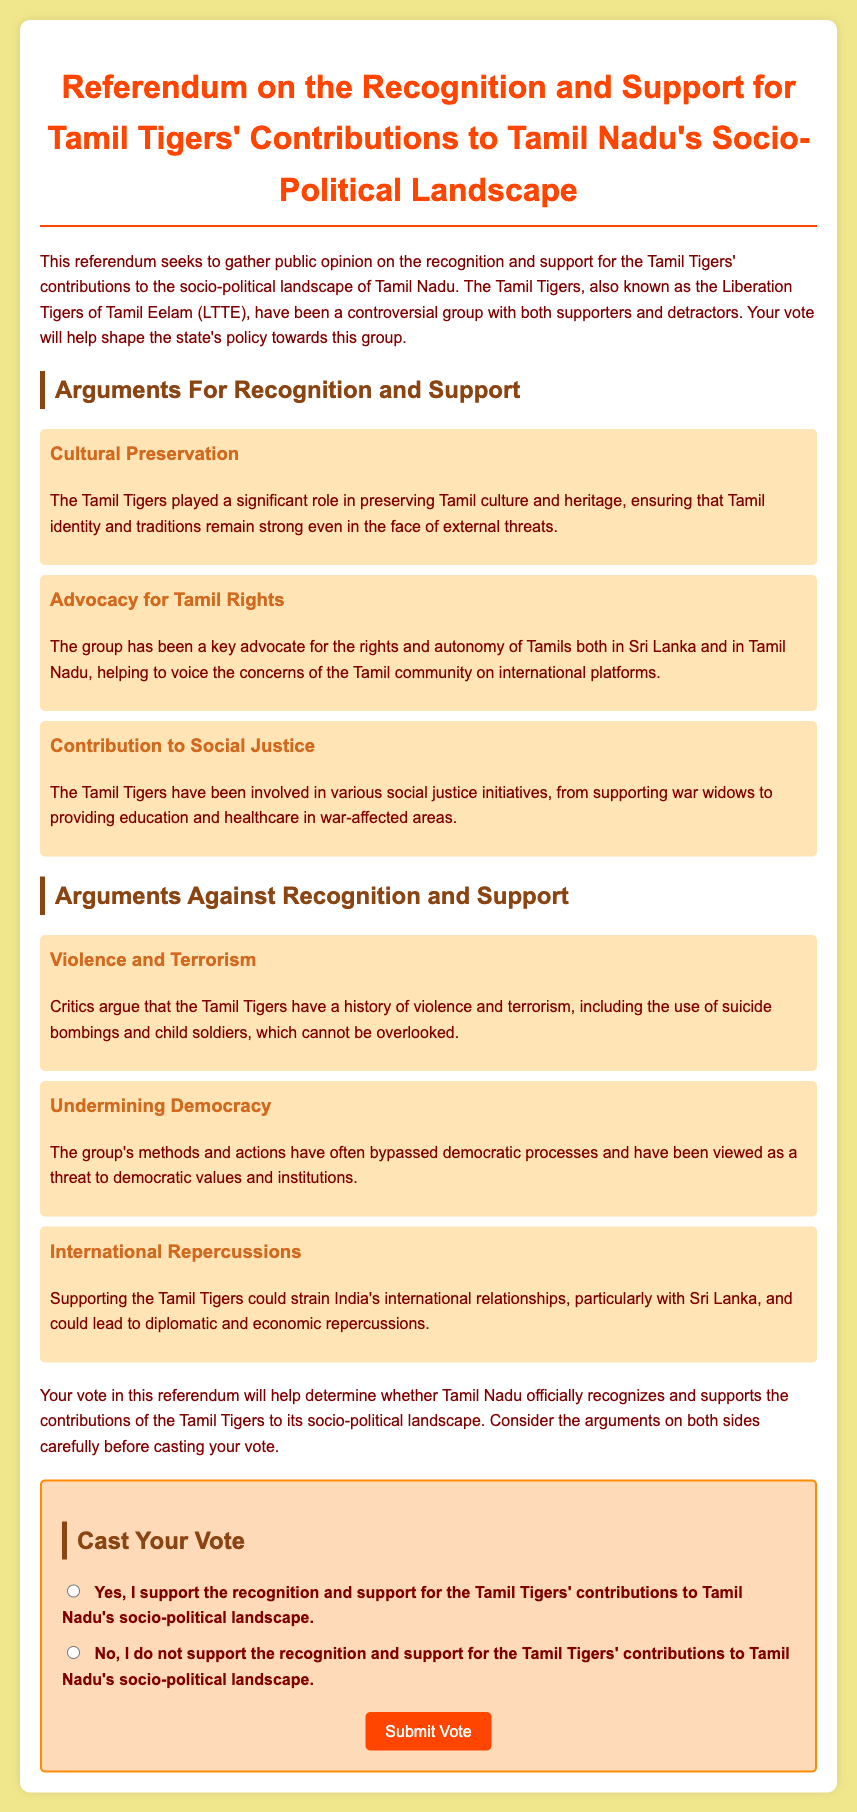What is the title of the referendum? The title is displayed prominently at the top of the document.
Answer: Referendum on the Recognition and Support for Tamil Tigers' Contributions to Tamil Nadu's Socio-Political Landscape Who are the Tamil Tigers also known as? The document mentions the alternative name for the Tamil Tigers.
Answer: Liberation Tigers of Tamil Eelam (LTTE) What is one argument for recognition and support? The document lists arguments for recognition and support, one of which is highlighted.
Answer: Cultural Preservation What is one argument against recognition and support? The document provides arguments against recognition and support, one of which is specified.
Answer: Violence and Terrorism How many arguments for recognition and support are presented? By counting the arguments listed in the document, we find the total number.
Answer: Three What color is the submit button? The document specifies the color of the button in its style section.
Answer: Orange What does your vote help determine? The document states the purpose of voting in the referendum.
Answer: Whether Tamil Nadu officially recognizes and supports the contributions of the Tamil Tigers Where can you cast your vote? The document describes the section where voting occurs.
Answer: In the ballot section 